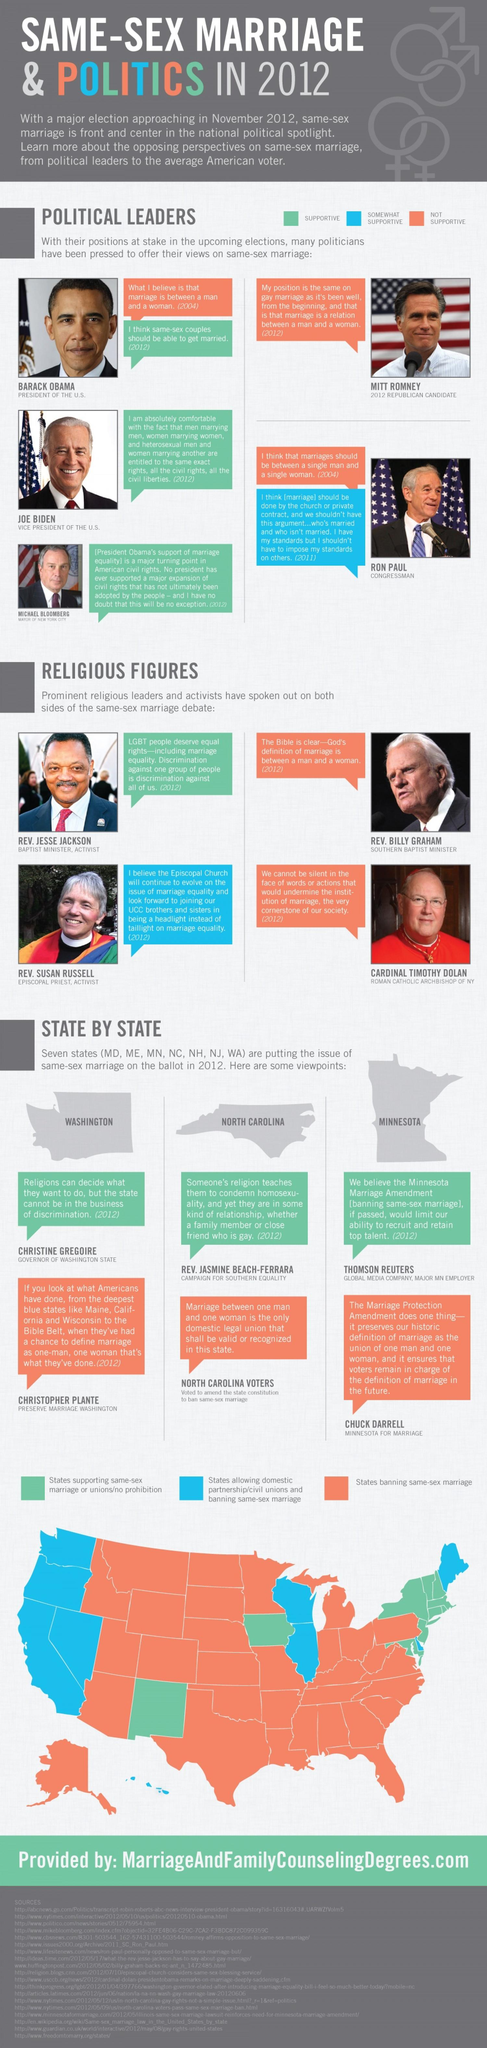Identify some key points in this picture. It has been reported that two political leaders hold different opinions on same-sex marriage. It is estimated that only two religious figures did not support same-sex marriage. According to my knowledge cutoff, there are at least three political leaders who exclusively hold the opinion that same-sex marriage should be legal. Three states currently allow same-sex marriage. There is at least one religious figure who fully supports same-sex marriage. 